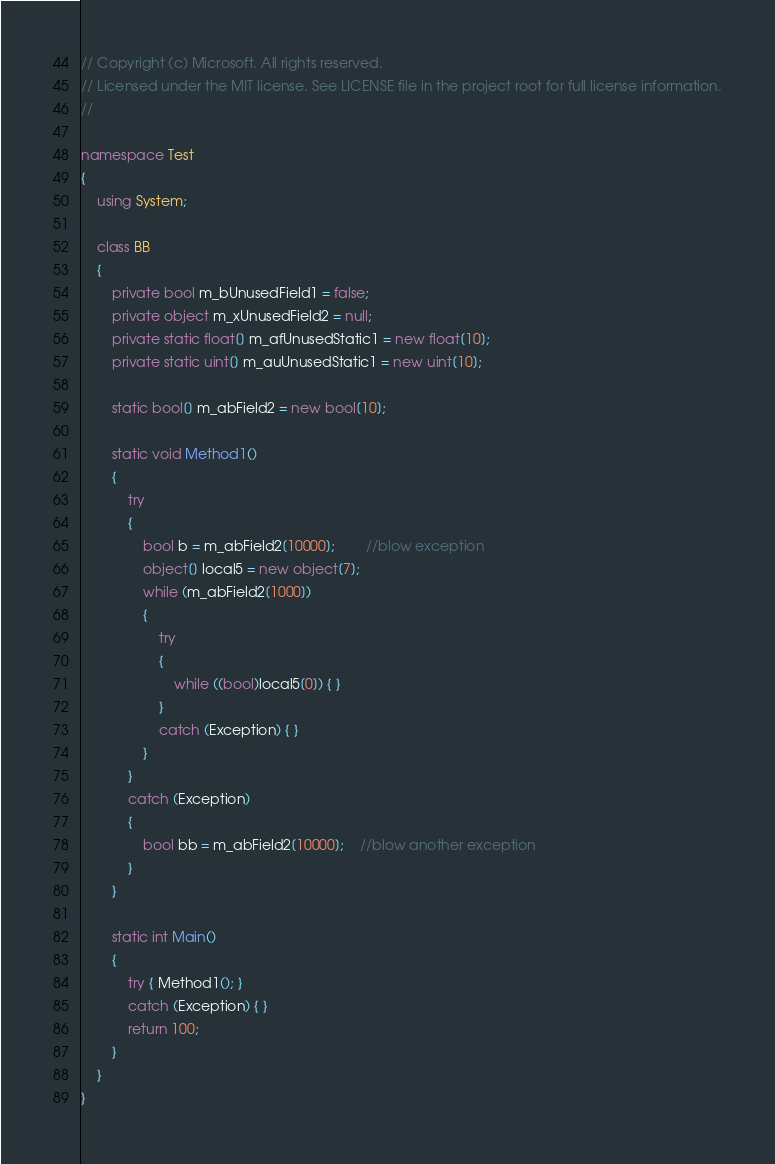<code> <loc_0><loc_0><loc_500><loc_500><_C#_>// Copyright (c) Microsoft. All rights reserved.
// Licensed under the MIT license. See LICENSE file in the project root for full license information.
//

namespace Test
{
    using System;

    class BB
    {
        private bool m_bUnusedField1 = false;
        private object m_xUnusedField2 = null;
        private static float[] m_afUnusedStatic1 = new float[10];
        private static uint[] m_auUnusedStatic1 = new uint[10];

        static bool[] m_abField2 = new bool[10];

        static void Method1()
        {
            try
            {
                bool b = m_abField2[10000];		//blow exception
                object[] local5 = new object[7];
                while (m_abField2[1000])
                {
                    try
                    {
                        while ((bool)local5[0]) { }
                    }
                    catch (Exception) { }
                }
            }
            catch (Exception)
            {
                bool bb = m_abField2[10000];	//blow another exception
            }
        }

        static int Main()
        {
            try { Method1(); }
            catch (Exception) { }
            return 100;
        }
    }
}
</code> 